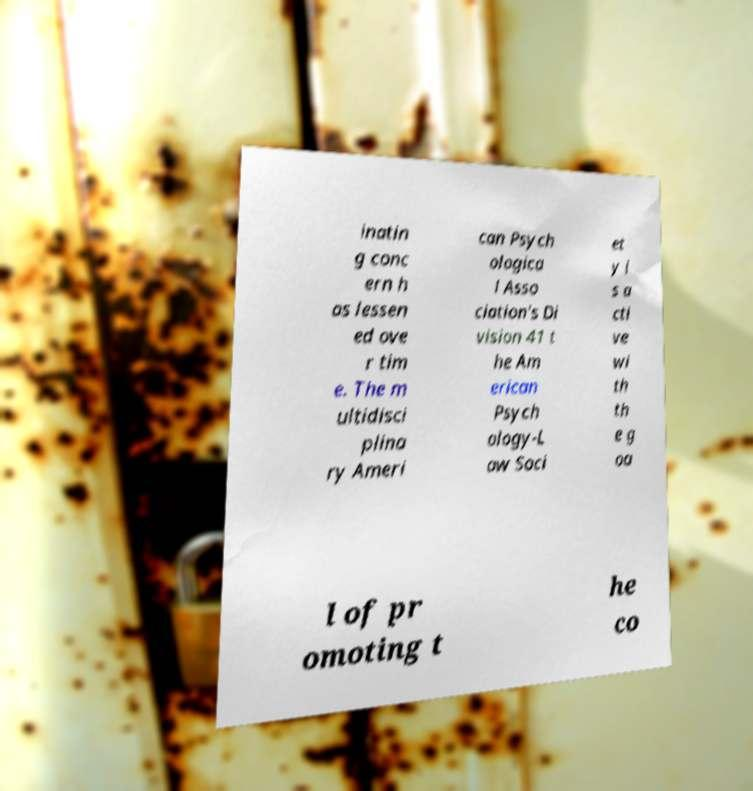Could you assist in decoding the text presented in this image and type it out clearly? inatin g conc ern h as lessen ed ove r tim e. The m ultidisci plina ry Ameri can Psych ologica l Asso ciation's Di vision 41 t he Am erican Psych ology-L aw Soci et y i s a cti ve wi th th e g oa l of pr omoting t he co 